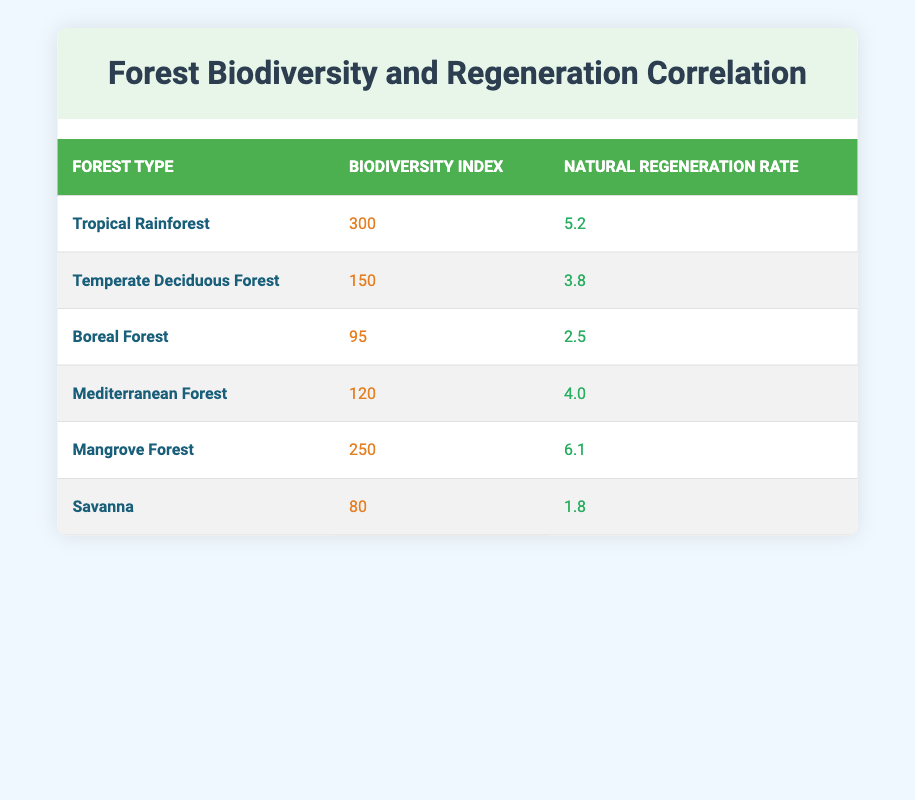What is the biodiversity index of the Tropical Rainforest? The biodiversity index for the Tropical Rainforest is listed directly in the table under the respective column, which shows a value of 300.
Answer: 300 Which forest type has the highest natural regeneration rate? By examining the natural regeneration rates provided in the table, the Mangrove Forest has the highest rate at 6.1.
Answer: Mangrove Forest What is the average biodiversity index across all forest types? To find the average, we need to sum up all the biodiversity indices (300 + 150 + 95 + 120 + 250 + 80 = 995) and divide by the number of forest types (6), which gives us 995/6 ≈ 165.83.
Answer: 165.83 Does the Savanna forest have a higher biodiversity index than the Boreal Forest? By comparing the values in the table, the Savanna forest has a biodiversity index of 80, while the Boreal Forest has an index of 95. Since 80 is less than 95, the statement is false.
Answer: No What is the difference in natural regeneration rate between the Tropical Rainforest and the Temperate Deciduous Forest? The natural regeneration rate for the Tropical Rainforest is 5.2, while for the Temperate Deciduous Forest it is 3.8. The difference is calculated as 5.2 - 3.8 = 1.4.
Answer: 1.4 Which forest type has a biodiversity index below 100? Looking through the table, we find the Boreal Forest with a biodiversity index of 95 and the Savanna with an index of 80; both are below 100.
Answer: Boreal Forest, Savanna Is there a forest type with a biodiversity index of 250? Checking the table, we can see that the Mangrove Forest indeed has a biodiversity index of 250. Thus, the statement is true.
Answer: Yes What is the sum of the natural regeneration rates for the Temperate Deciduous Forest and the Boreal Forest? The natural regeneration rate for the Temperate Deciduous Forest is 3.8 and for the Boreal Forest it's 2.5. Summing these gives 3.8 + 2.5 = 6.3 for the two forest types together.
Answer: 6.3 Which forest types have a biodiversity index greater than 200? By reviewing the biodiversity indices listed in the table, only the Tropical Rainforest (300) and Mangrove Forest (250) have indices greater than 200.
Answer: Tropical Rainforest, Mangrove Forest 